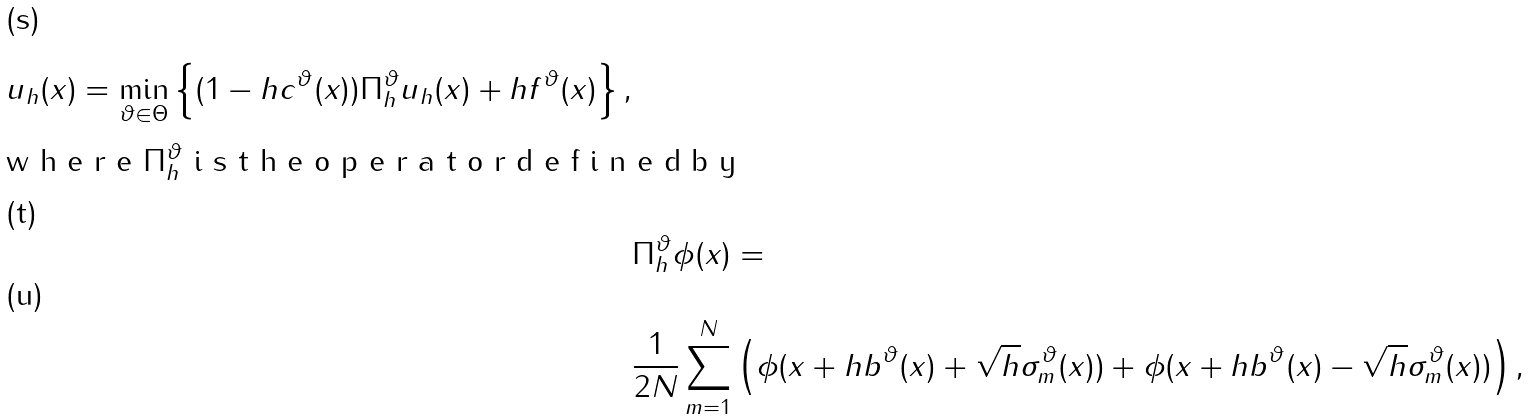<formula> <loc_0><loc_0><loc_500><loc_500>u _ { h } ( x ) = \min _ { \vartheta \in \Theta } \left \{ ( 1 - h c ^ { \vartheta } ( x ) ) \Pi _ { h } ^ { \vartheta } u _ { h } ( x ) + h f ^ { \vartheta } ( x ) \right \} , \\ \intertext { w h e r e $ \Pi _ { h } ^ { \vartheta } $ i s t h e o p e r a t o r d e f i n e d b y } & \Pi _ { h } ^ { \vartheta } \phi ( x ) = \\ & \frac { 1 } { 2 N } \sum _ { m = 1 } ^ { N } \left ( \phi ( x + h b ^ { \vartheta } ( x ) + \sqrt { h } \sigma ^ { \vartheta } _ { m } ( x ) ) + \phi ( x + h b ^ { \vartheta } ( x ) - \sqrt { h } \sigma ^ { \vartheta } _ { m } ( x ) ) \right ) ,</formula> 